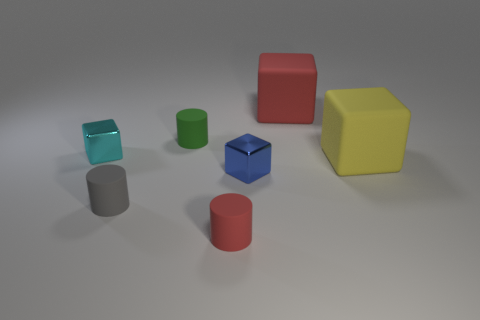What number of objects are either small gray rubber cylinders or big matte spheres?
Provide a short and direct response. 1. What color is the other metallic cube that is the same size as the cyan block?
Offer a very short reply. Blue. There is a cyan object; is its shape the same as the red object behind the small cyan shiny cube?
Provide a succinct answer. Yes. How many things are either red objects that are in front of the small gray thing or large objects behind the yellow thing?
Your answer should be compact. 2. There is a metallic object to the right of the small red cylinder; what is its shape?
Make the answer very short. Cube. There is a red object to the left of the big red matte cube; is it the same shape as the small cyan metallic object?
Make the answer very short. No. How many things are either matte cylinders that are in front of the small green rubber cylinder or tiny gray matte things?
Make the answer very short. 2. The other small metallic thing that is the same shape as the blue thing is what color?
Offer a terse response. Cyan. What size is the metallic block that is behind the tiny blue thing?
Your answer should be compact. Small. What number of other objects are the same material as the gray cylinder?
Make the answer very short. 4. 